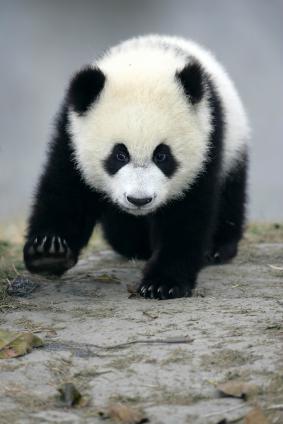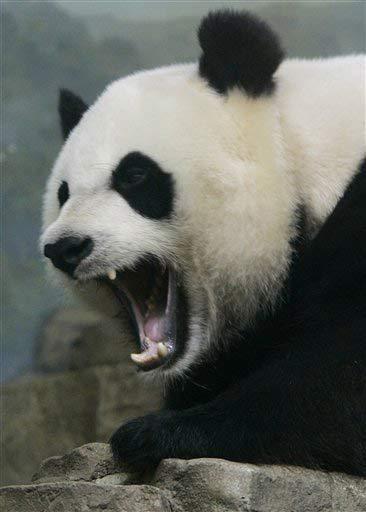The first image is the image on the left, the second image is the image on the right. Considering the images on both sides, is "In one of the images there is a mother panda with her baby." valid? Answer yes or no. No. The first image is the image on the left, the second image is the image on the right. Analyze the images presented: Is the assertion "There are two panda bears" valid? Answer yes or no. Yes. 